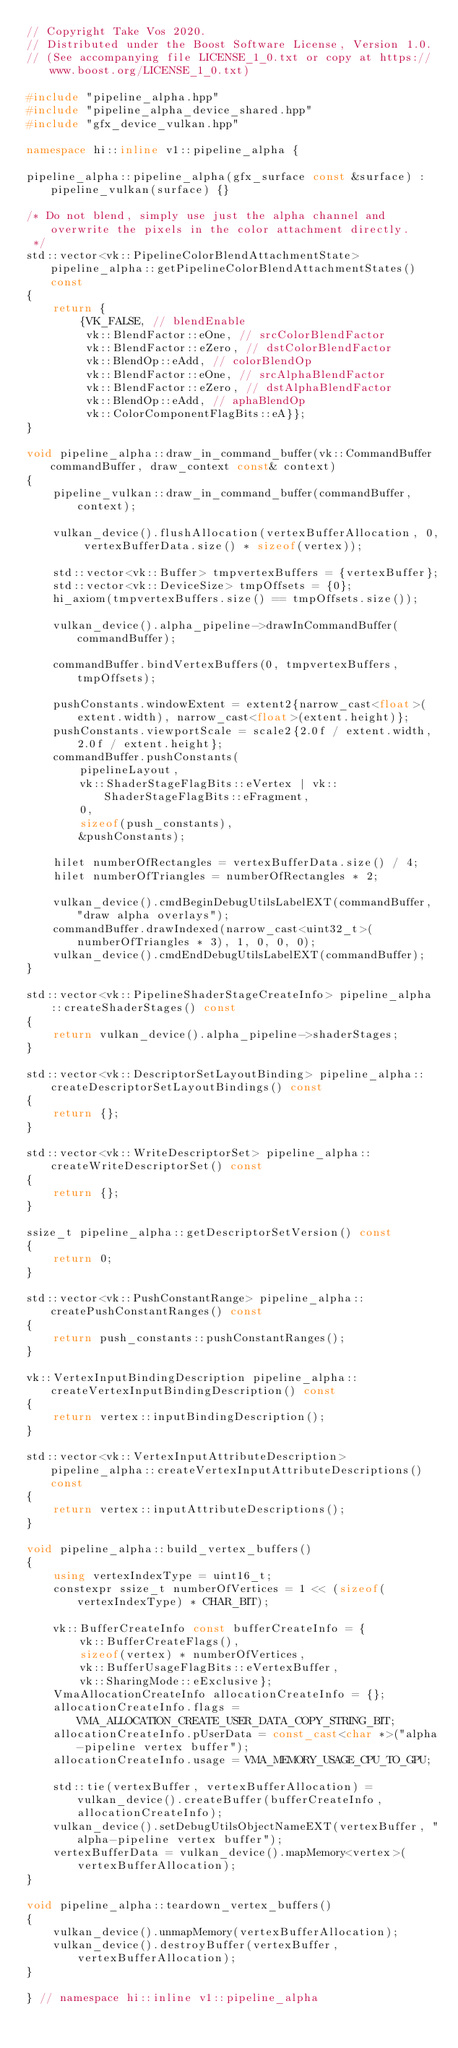Convert code to text. <code><loc_0><loc_0><loc_500><loc_500><_C++_>// Copyright Take Vos 2020.
// Distributed under the Boost Software License, Version 1.0.
// (See accompanying file LICENSE_1_0.txt or copy at https://www.boost.org/LICENSE_1_0.txt)

#include "pipeline_alpha.hpp"
#include "pipeline_alpha_device_shared.hpp"
#include "gfx_device_vulkan.hpp"

namespace hi::inline v1::pipeline_alpha {

pipeline_alpha::pipeline_alpha(gfx_surface const &surface) : pipeline_vulkan(surface) {}

/* Do not blend, simply use just the alpha channel and overwrite the pixels in the color attachment directly.
 */
std::vector<vk::PipelineColorBlendAttachmentState> pipeline_alpha::getPipelineColorBlendAttachmentStates() const
{
    return {
        {VK_FALSE, // blendEnable
         vk::BlendFactor::eOne, // srcColorBlendFactor
         vk::BlendFactor::eZero, // dstColorBlendFactor
         vk::BlendOp::eAdd, // colorBlendOp
         vk::BlendFactor::eOne, // srcAlphaBlendFactor
         vk::BlendFactor::eZero, // dstAlphaBlendFactor
         vk::BlendOp::eAdd, // aphaBlendOp
         vk::ColorComponentFlagBits::eA}};
}

void pipeline_alpha::draw_in_command_buffer(vk::CommandBuffer commandBuffer, draw_context const& context)
{
    pipeline_vulkan::draw_in_command_buffer(commandBuffer, context);

    vulkan_device().flushAllocation(vertexBufferAllocation, 0, vertexBufferData.size() * sizeof(vertex));

    std::vector<vk::Buffer> tmpvertexBuffers = {vertexBuffer};
    std::vector<vk::DeviceSize> tmpOffsets = {0};
    hi_axiom(tmpvertexBuffers.size() == tmpOffsets.size());

    vulkan_device().alpha_pipeline->drawInCommandBuffer(commandBuffer);

    commandBuffer.bindVertexBuffers(0, tmpvertexBuffers, tmpOffsets);

    pushConstants.windowExtent = extent2{narrow_cast<float>(extent.width), narrow_cast<float>(extent.height)};
    pushConstants.viewportScale = scale2{2.0f / extent.width, 2.0f / extent.height};
    commandBuffer.pushConstants(
        pipelineLayout,
        vk::ShaderStageFlagBits::eVertex | vk::ShaderStageFlagBits::eFragment,
        0,
        sizeof(push_constants),
        &pushConstants);

    hilet numberOfRectangles = vertexBufferData.size() / 4;
    hilet numberOfTriangles = numberOfRectangles * 2;

    vulkan_device().cmdBeginDebugUtilsLabelEXT(commandBuffer, "draw alpha overlays");
    commandBuffer.drawIndexed(narrow_cast<uint32_t>(numberOfTriangles * 3), 1, 0, 0, 0);
    vulkan_device().cmdEndDebugUtilsLabelEXT(commandBuffer);
}

std::vector<vk::PipelineShaderStageCreateInfo> pipeline_alpha::createShaderStages() const
{
    return vulkan_device().alpha_pipeline->shaderStages;
}

std::vector<vk::DescriptorSetLayoutBinding> pipeline_alpha::createDescriptorSetLayoutBindings() const
{
    return {};
}

std::vector<vk::WriteDescriptorSet> pipeline_alpha::createWriteDescriptorSet() const
{
    return {};
}

ssize_t pipeline_alpha::getDescriptorSetVersion() const
{
    return 0;
}

std::vector<vk::PushConstantRange> pipeline_alpha::createPushConstantRanges() const
{
    return push_constants::pushConstantRanges();
}

vk::VertexInputBindingDescription pipeline_alpha::createVertexInputBindingDescription() const
{
    return vertex::inputBindingDescription();
}

std::vector<vk::VertexInputAttributeDescription> pipeline_alpha::createVertexInputAttributeDescriptions() const
{
    return vertex::inputAttributeDescriptions();
}

void pipeline_alpha::build_vertex_buffers()
{
    using vertexIndexType = uint16_t;
    constexpr ssize_t numberOfVertices = 1 << (sizeof(vertexIndexType) * CHAR_BIT);

    vk::BufferCreateInfo const bufferCreateInfo = {
        vk::BufferCreateFlags(),
        sizeof(vertex) * numberOfVertices,
        vk::BufferUsageFlagBits::eVertexBuffer,
        vk::SharingMode::eExclusive};
    VmaAllocationCreateInfo allocationCreateInfo = {};
    allocationCreateInfo.flags = VMA_ALLOCATION_CREATE_USER_DATA_COPY_STRING_BIT;
    allocationCreateInfo.pUserData = const_cast<char *>("alpha-pipeline vertex buffer");
    allocationCreateInfo.usage = VMA_MEMORY_USAGE_CPU_TO_GPU;

    std::tie(vertexBuffer, vertexBufferAllocation) = vulkan_device().createBuffer(bufferCreateInfo, allocationCreateInfo);
    vulkan_device().setDebugUtilsObjectNameEXT(vertexBuffer, "alpha-pipeline vertex buffer");
    vertexBufferData = vulkan_device().mapMemory<vertex>(vertexBufferAllocation);
}

void pipeline_alpha::teardown_vertex_buffers()
{
    vulkan_device().unmapMemory(vertexBufferAllocation);
    vulkan_device().destroyBuffer(vertexBuffer, vertexBufferAllocation);
}

} // namespace hi::inline v1::pipeline_alpha
</code> 